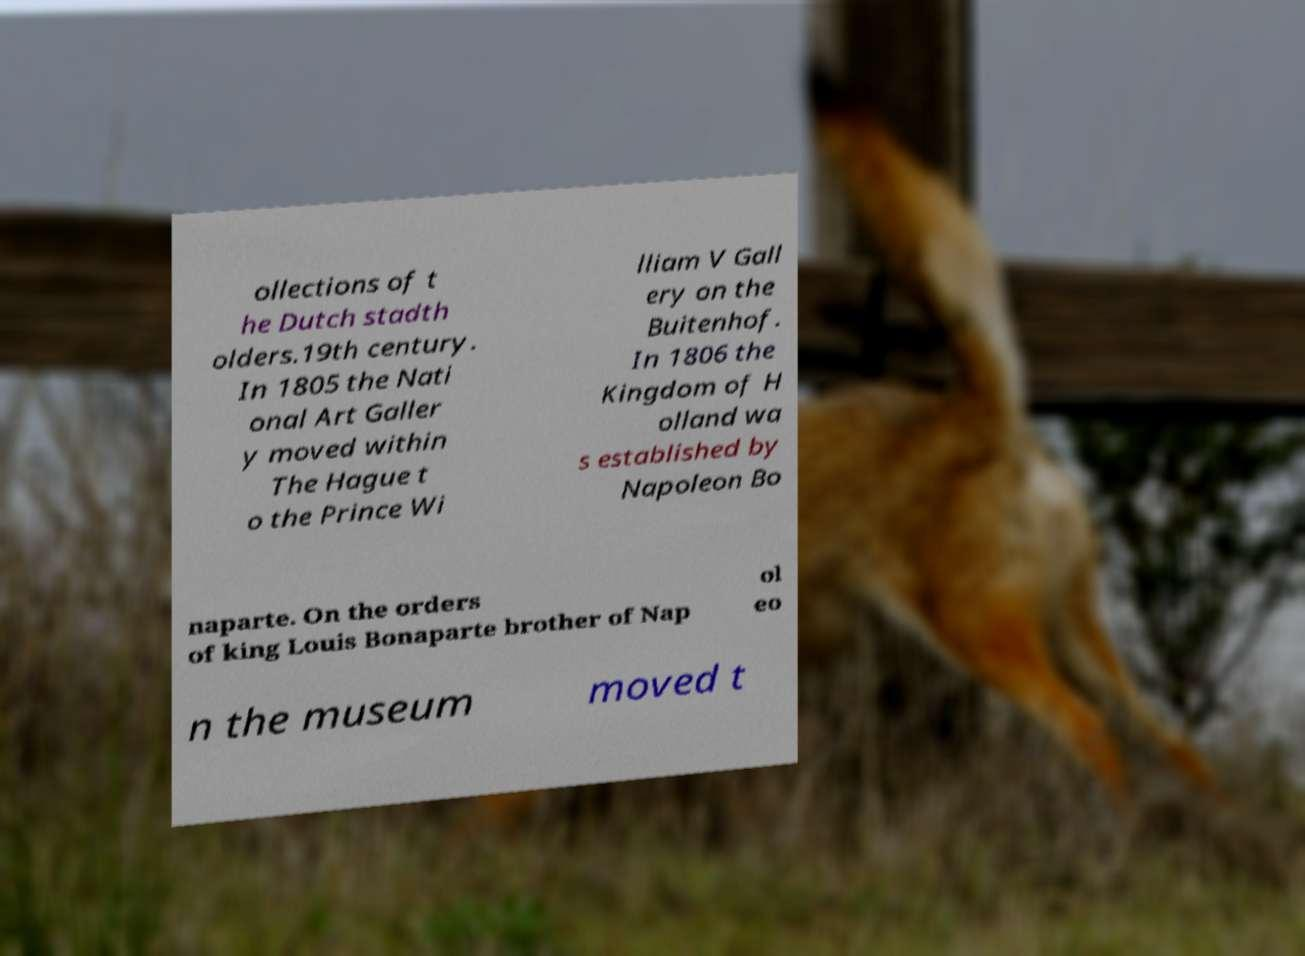Could you assist in decoding the text presented in this image and type it out clearly? ollections of t he Dutch stadth olders.19th century. In 1805 the Nati onal Art Galler y moved within The Hague t o the Prince Wi lliam V Gall ery on the Buitenhof. In 1806 the Kingdom of H olland wa s established by Napoleon Bo naparte. On the orders of king Louis Bonaparte brother of Nap ol eo n the museum moved t 